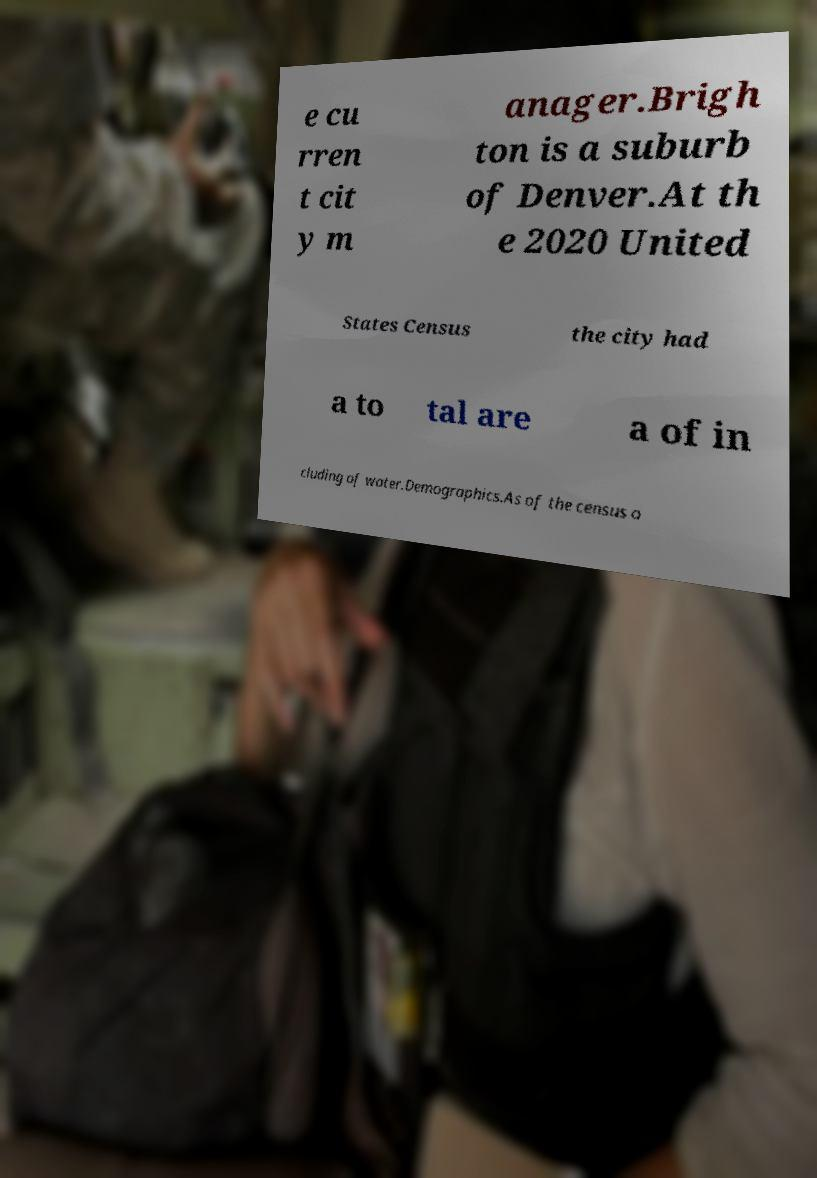Can you accurately transcribe the text from the provided image for me? e cu rren t cit y m anager.Brigh ton is a suburb of Denver.At th e 2020 United States Census the city had a to tal are a of in cluding of water.Demographics.As of the census o 